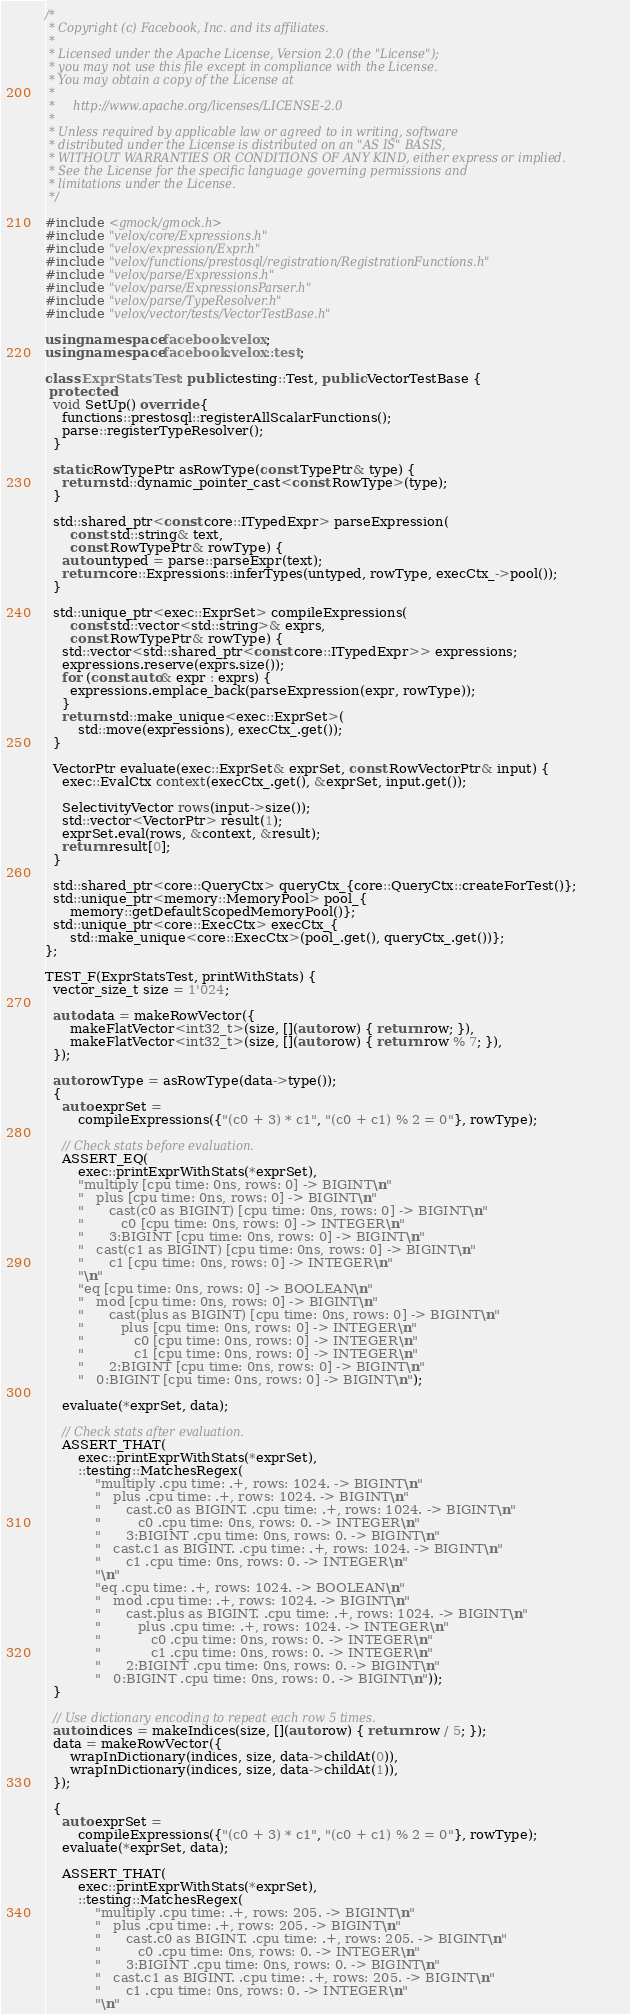Convert code to text. <code><loc_0><loc_0><loc_500><loc_500><_C++_>/*
 * Copyright (c) Facebook, Inc. and its affiliates.
 *
 * Licensed under the Apache License, Version 2.0 (the "License");
 * you may not use this file except in compliance with the License.
 * You may obtain a copy of the License at
 *
 *     http://www.apache.org/licenses/LICENSE-2.0
 *
 * Unless required by applicable law or agreed to in writing, software
 * distributed under the License is distributed on an "AS IS" BASIS,
 * WITHOUT WARRANTIES OR CONDITIONS OF ANY KIND, either express or implied.
 * See the License for the specific language governing permissions and
 * limitations under the License.
 */

#include <gmock/gmock.h>
#include "velox/core/Expressions.h"
#include "velox/expression/Expr.h"
#include "velox/functions/prestosql/registration/RegistrationFunctions.h"
#include "velox/parse/Expressions.h"
#include "velox/parse/ExpressionsParser.h"
#include "velox/parse/TypeResolver.h"
#include "velox/vector/tests/VectorTestBase.h"

using namespace facebook::velox;
using namespace facebook::velox::test;

class ExprStatsTest : public testing::Test, public VectorTestBase {
 protected:
  void SetUp() override {
    functions::prestosql::registerAllScalarFunctions();
    parse::registerTypeResolver();
  }

  static RowTypePtr asRowType(const TypePtr& type) {
    return std::dynamic_pointer_cast<const RowType>(type);
  }

  std::shared_ptr<const core::ITypedExpr> parseExpression(
      const std::string& text,
      const RowTypePtr& rowType) {
    auto untyped = parse::parseExpr(text);
    return core::Expressions::inferTypes(untyped, rowType, execCtx_->pool());
  }

  std::unique_ptr<exec::ExprSet> compileExpressions(
      const std::vector<std::string>& exprs,
      const RowTypePtr& rowType) {
    std::vector<std::shared_ptr<const core::ITypedExpr>> expressions;
    expressions.reserve(exprs.size());
    for (const auto& expr : exprs) {
      expressions.emplace_back(parseExpression(expr, rowType));
    }
    return std::make_unique<exec::ExprSet>(
        std::move(expressions), execCtx_.get());
  }

  VectorPtr evaluate(exec::ExprSet& exprSet, const RowVectorPtr& input) {
    exec::EvalCtx context(execCtx_.get(), &exprSet, input.get());

    SelectivityVector rows(input->size());
    std::vector<VectorPtr> result(1);
    exprSet.eval(rows, &context, &result);
    return result[0];
  }

  std::shared_ptr<core::QueryCtx> queryCtx_{core::QueryCtx::createForTest()};
  std::unique_ptr<memory::MemoryPool> pool_{
      memory::getDefaultScopedMemoryPool()};
  std::unique_ptr<core::ExecCtx> execCtx_{
      std::make_unique<core::ExecCtx>(pool_.get(), queryCtx_.get())};
};

TEST_F(ExprStatsTest, printWithStats) {
  vector_size_t size = 1'024;

  auto data = makeRowVector({
      makeFlatVector<int32_t>(size, [](auto row) { return row; }),
      makeFlatVector<int32_t>(size, [](auto row) { return row % 7; }),
  });

  auto rowType = asRowType(data->type());
  {
    auto exprSet =
        compileExpressions({"(c0 + 3) * c1", "(c0 + c1) % 2 = 0"}, rowType);

    // Check stats before evaluation.
    ASSERT_EQ(
        exec::printExprWithStats(*exprSet),
        "multiply [cpu time: 0ns, rows: 0] -> BIGINT\n"
        "   plus [cpu time: 0ns, rows: 0] -> BIGINT\n"
        "      cast(c0 as BIGINT) [cpu time: 0ns, rows: 0] -> BIGINT\n"
        "         c0 [cpu time: 0ns, rows: 0] -> INTEGER\n"
        "      3:BIGINT [cpu time: 0ns, rows: 0] -> BIGINT\n"
        "   cast(c1 as BIGINT) [cpu time: 0ns, rows: 0] -> BIGINT\n"
        "      c1 [cpu time: 0ns, rows: 0] -> INTEGER\n"
        "\n"
        "eq [cpu time: 0ns, rows: 0] -> BOOLEAN\n"
        "   mod [cpu time: 0ns, rows: 0] -> BIGINT\n"
        "      cast(plus as BIGINT) [cpu time: 0ns, rows: 0] -> BIGINT\n"
        "         plus [cpu time: 0ns, rows: 0] -> INTEGER\n"
        "            c0 [cpu time: 0ns, rows: 0] -> INTEGER\n"
        "            c1 [cpu time: 0ns, rows: 0] -> INTEGER\n"
        "      2:BIGINT [cpu time: 0ns, rows: 0] -> BIGINT\n"
        "   0:BIGINT [cpu time: 0ns, rows: 0] -> BIGINT\n");

    evaluate(*exprSet, data);

    // Check stats after evaluation.
    ASSERT_THAT(
        exec::printExprWithStats(*exprSet),
        ::testing::MatchesRegex(
            "multiply .cpu time: .+, rows: 1024. -> BIGINT\n"
            "   plus .cpu time: .+, rows: 1024. -> BIGINT\n"
            "      cast.c0 as BIGINT. .cpu time: .+, rows: 1024. -> BIGINT\n"
            "         c0 .cpu time: 0ns, rows: 0. -> INTEGER\n"
            "      3:BIGINT .cpu time: 0ns, rows: 0. -> BIGINT\n"
            "   cast.c1 as BIGINT. .cpu time: .+, rows: 1024. -> BIGINT\n"
            "      c1 .cpu time: 0ns, rows: 0. -> INTEGER\n"
            "\n"
            "eq .cpu time: .+, rows: 1024. -> BOOLEAN\n"
            "   mod .cpu time: .+, rows: 1024. -> BIGINT\n"
            "      cast.plus as BIGINT. .cpu time: .+, rows: 1024. -> BIGINT\n"
            "         plus .cpu time: .+, rows: 1024. -> INTEGER\n"
            "            c0 .cpu time: 0ns, rows: 0. -> INTEGER\n"
            "            c1 .cpu time: 0ns, rows: 0. -> INTEGER\n"
            "      2:BIGINT .cpu time: 0ns, rows: 0. -> BIGINT\n"
            "   0:BIGINT .cpu time: 0ns, rows: 0. -> BIGINT\n"));
  }

  // Use dictionary encoding to repeat each row 5 times.
  auto indices = makeIndices(size, [](auto row) { return row / 5; });
  data = makeRowVector({
      wrapInDictionary(indices, size, data->childAt(0)),
      wrapInDictionary(indices, size, data->childAt(1)),
  });

  {
    auto exprSet =
        compileExpressions({"(c0 + 3) * c1", "(c0 + c1) % 2 = 0"}, rowType);
    evaluate(*exprSet, data);

    ASSERT_THAT(
        exec::printExprWithStats(*exprSet),
        ::testing::MatchesRegex(
            "multiply .cpu time: .+, rows: 205. -> BIGINT\n"
            "   plus .cpu time: .+, rows: 205. -> BIGINT\n"
            "      cast.c0 as BIGINT. .cpu time: .+, rows: 205. -> BIGINT\n"
            "         c0 .cpu time: 0ns, rows: 0. -> INTEGER\n"
            "      3:BIGINT .cpu time: 0ns, rows: 0. -> BIGINT\n"
            "   cast.c1 as BIGINT. .cpu time: .+, rows: 205. -> BIGINT\n"
            "      c1 .cpu time: 0ns, rows: 0. -> INTEGER\n"
            "\n"</code> 